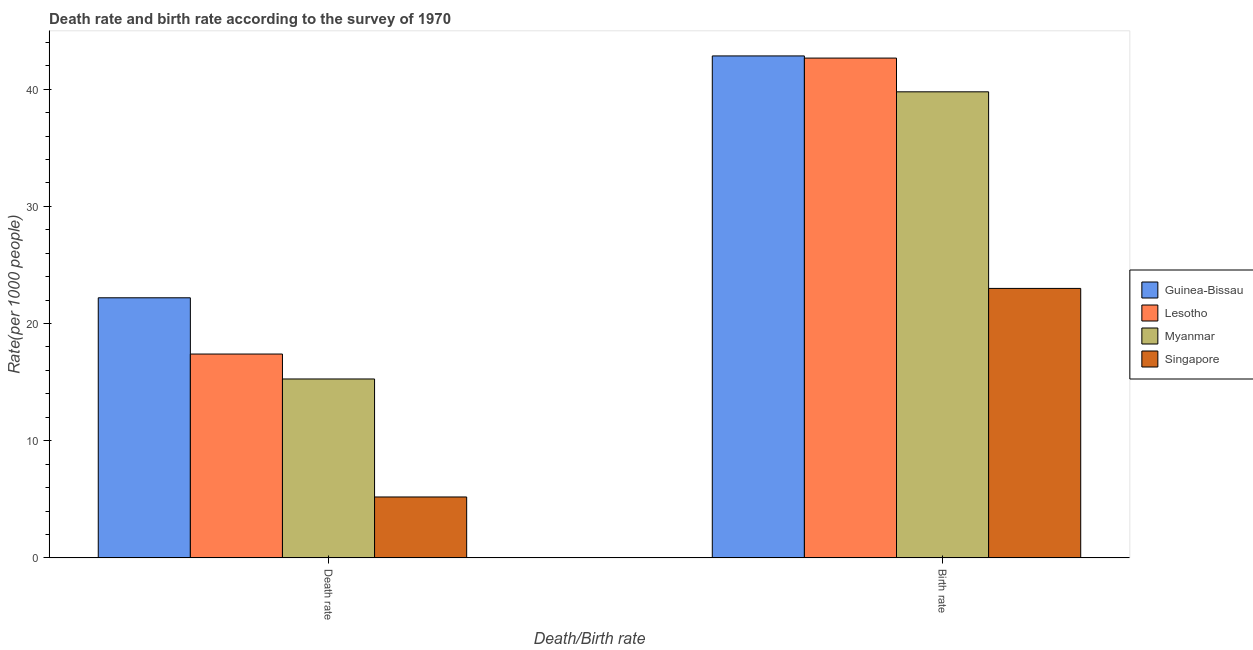How many groups of bars are there?
Your response must be concise. 2. Are the number of bars per tick equal to the number of legend labels?
Your answer should be very brief. Yes. How many bars are there on the 2nd tick from the left?
Your answer should be very brief. 4. How many bars are there on the 2nd tick from the right?
Make the answer very short. 4. What is the label of the 1st group of bars from the left?
Provide a short and direct response. Death rate. What is the death rate in Guinea-Bissau?
Your answer should be very brief. 22.2. Across all countries, what is the maximum death rate?
Your answer should be compact. 22.2. In which country was the death rate maximum?
Ensure brevity in your answer.  Guinea-Bissau. In which country was the birth rate minimum?
Your answer should be very brief. Singapore. What is the total birth rate in the graph?
Keep it short and to the point. 148.28. What is the difference between the birth rate in Lesotho and that in Myanmar?
Offer a terse response. 2.88. What is the difference between the birth rate in Lesotho and the death rate in Myanmar?
Ensure brevity in your answer.  27.39. What is the average death rate per country?
Your answer should be compact. 15.02. What is the difference between the death rate and birth rate in Guinea-Bissau?
Offer a very short reply. -20.64. What is the ratio of the death rate in Guinea-Bissau to that in Singapore?
Your response must be concise. 4.27. In how many countries, is the birth rate greater than the average birth rate taken over all countries?
Provide a short and direct response. 3. What does the 3rd bar from the left in Death rate represents?
Offer a terse response. Myanmar. What does the 1st bar from the right in Death rate represents?
Give a very brief answer. Singapore. How many countries are there in the graph?
Your answer should be very brief. 4. What is the difference between two consecutive major ticks on the Y-axis?
Make the answer very short. 10. Are the values on the major ticks of Y-axis written in scientific E-notation?
Provide a succinct answer. No. Does the graph contain any zero values?
Ensure brevity in your answer.  No. Does the graph contain grids?
Your answer should be very brief. No. How many legend labels are there?
Provide a short and direct response. 4. How are the legend labels stacked?
Your response must be concise. Vertical. What is the title of the graph?
Provide a succinct answer. Death rate and birth rate according to the survey of 1970. Does "Trinidad and Tobago" appear as one of the legend labels in the graph?
Your response must be concise. No. What is the label or title of the X-axis?
Ensure brevity in your answer.  Death/Birth rate. What is the label or title of the Y-axis?
Give a very brief answer. Rate(per 1000 people). What is the Rate(per 1000 people) in Guinea-Bissau in Death rate?
Your response must be concise. 22.2. What is the Rate(per 1000 people) of Lesotho in Death rate?
Provide a succinct answer. 17.4. What is the Rate(per 1000 people) in Myanmar in Death rate?
Provide a short and direct response. 15.27. What is the Rate(per 1000 people) in Guinea-Bissau in Birth rate?
Ensure brevity in your answer.  42.84. What is the Rate(per 1000 people) of Lesotho in Birth rate?
Your response must be concise. 42.66. What is the Rate(per 1000 people) of Myanmar in Birth rate?
Offer a terse response. 39.78. Across all Death/Birth rate, what is the maximum Rate(per 1000 people) in Guinea-Bissau?
Ensure brevity in your answer.  42.84. Across all Death/Birth rate, what is the maximum Rate(per 1000 people) of Lesotho?
Provide a succinct answer. 42.66. Across all Death/Birth rate, what is the maximum Rate(per 1000 people) of Myanmar?
Provide a short and direct response. 39.78. Across all Death/Birth rate, what is the minimum Rate(per 1000 people) in Guinea-Bissau?
Offer a terse response. 22.2. Across all Death/Birth rate, what is the minimum Rate(per 1000 people) of Lesotho?
Provide a short and direct response. 17.4. Across all Death/Birth rate, what is the minimum Rate(per 1000 people) in Myanmar?
Ensure brevity in your answer.  15.27. What is the total Rate(per 1000 people) in Guinea-Bissau in the graph?
Ensure brevity in your answer.  65.04. What is the total Rate(per 1000 people) in Lesotho in the graph?
Ensure brevity in your answer.  60.06. What is the total Rate(per 1000 people) in Myanmar in the graph?
Provide a succinct answer. 55.05. What is the total Rate(per 1000 people) of Singapore in the graph?
Make the answer very short. 28.2. What is the difference between the Rate(per 1000 people) of Guinea-Bissau in Death rate and that in Birth rate?
Ensure brevity in your answer.  -20.64. What is the difference between the Rate(per 1000 people) of Lesotho in Death rate and that in Birth rate?
Ensure brevity in your answer.  -25.26. What is the difference between the Rate(per 1000 people) in Myanmar in Death rate and that in Birth rate?
Make the answer very short. -24.51. What is the difference between the Rate(per 1000 people) of Singapore in Death rate and that in Birth rate?
Make the answer very short. -17.8. What is the difference between the Rate(per 1000 people) in Guinea-Bissau in Death rate and the Rate(per 1000 people) in Lesotho in Birth rate?
Your answer should be compact. -20.46. What is the difference between the Rate(per 1000 people) of Guinea-Bissau in Death rate and the Rate(per 1000 people) of Myanmar in Birth rate?
Your answer should be compact. -17.58. What is the difference between the Rate(per 1000 people) of Guinea-Bissau in Death rate and the Rate(per 1000 people) of Singapore in Birth rate?
Ensure brevity in your answer.  -0.8. What is the difference between the Rate(per 1000 people) of Lesotho in Death rate and the Rate(per 1000 people) of Myanmar in Birth rate?
Provide a succinct answer. -22.38. What is the difference between the Rate(per 1000 people) of Lesotho in Death rate and the Rate(per 1000 people) of Singapore in Birth rate?
Give a very brief answer. -5.6. What is the difference between the Rate(per 1000 people) of Myanmar in Death rate and the Rate(per 1000 people) of Singapore in Birth rate?
Offer a very short reply. -7.73. What is the average Rate(per 1000 people) in Guinea-Bissau per Death/Birth rate?
Offer a terse response. 32.52. What is the average Rate(per 1000 people) of Lesotho per Death/Birth rate?
Your answer should be very brief. 30.03. What is the average Rate(per 1000 people) of Myanmar per Death/Birth rate?
Provide a short and direct response. 27.52. What is the average Rate(per 1000 people) of Singapore per Death/Birth rate?
Your answer should be very brief. 14.1. What is the difference between the Rate(per 1000 people) in Guinea-Bissau and Rate(per 1000 people) in Lesotho in Death rate?
Give a very brief answer. 4.8. What is the difference between the Rate(per 1000 people) of Guinea-Bissau and Rate(per 1000 people) of Myanmar in Death rate?
Offer a very short reply. 6.93. What is the difference between the Rate(per 1000 people) in Guinea-Bissau and Rate(per 1000 people) in Singapore in Death rate?
Offer a terse response. 17. What is the difference between the Rate(per 1000 people) of Lesotho and Rate(per 1000 people) of Myanmar in Death rate?
Ensure brevity in your answer.  2.13. What is the difference between the Rate(per 1000 people) in Lesotho and Rate(per 1000 people) in Singapore in Death rate?
Provide a short and direct response. 12.2. What is the difference between the Rate(per 1000 people) in Myanmar and Rate(per 1000 people) in Singapore in Death rate?
Provide a short and direct response. 10.07. What is the difference between the Rate(per 1000 people) of Guinea-Bissau and Rate(per 1000 people) of Lesotho in Birth rate?
Your response must be concise. 0.18. What is the difference between the Rate(per 1000 people) of Guinea-Bissau and Rate(per 1000 people) of Myanmar in Birth rate?
Your answer should be very brief. 3.06. What is the difference between the Rate(per 1000 people) of Guinea-Bissau and Rate(per 1000 people) of Singapore in Birth rate?
Give a very brief answer. 19.84. What is the difference between the Rate(per 1000 people) in Lesotho and Rate(per 1000 people) in Myanmar in Birth rate?
Keep it short and to the point. 2.88. What is the difference between the Rate(per 1000 people) in Lesotho and Rate(per 1000 people) in Singapore in Birth rate?
Your answer should be very brief. 19.66. What is the difference between the Rate(per 1000 people) in Myanmar and Rate(per 1000 people) in Singapore in Birth rate?
Ensure brevity in your answer.  16.78. What is the ratio of the Rate(per 1000 people) of Guinea-Bissau in Death rate to that in Birth rate?
Make the answer very short. 0.52. What is the ratio of the Rate(per 1000 people) of Lesotho in Death rate to that in Birth rate?
Ensure brevity in your answer.  0.41. What is the ratio of the Rate(per 1000 people) in Myanmar in Death rate to that in Birth rate?
Your answer should be very brief. 0.38. What is the ratio of the Rate(per 1000 people) of Singapore in Death rate to that in Birth rate?
Offer a very short reply. 0.23. What is the difference between the highest and the second highest Rate(per 1000 people) of Guinea-Bissau?
Offer a very short reply. 20.64. What is the difference between the highest and the second highest Rate(per 1000 people) of Lesotho?
Offer a very short reply. 25.26. What is the difference between the highest and the second highest Rate(per 1000 people) of Myanmar?
Your answer should be compact. 24.51. What is the difference between the highest and the lowest Rate(per 1000 people) of Guinea-Bissau?
Your answer should be very brief. 20.64. What is the difference between the highest and the lowest Rate(per 1000 people) in Lesotho?
Provide a short and direct response. 25.26. What is the difference between the highest and the lowest Rate(per 1000 people) in Myanmar?
Keep it short and to the point. 24.51. What is the difference between the highest and the lowest Rate(per 1000 people) of Singapore?
Keep it short and to the point. 17.8. 